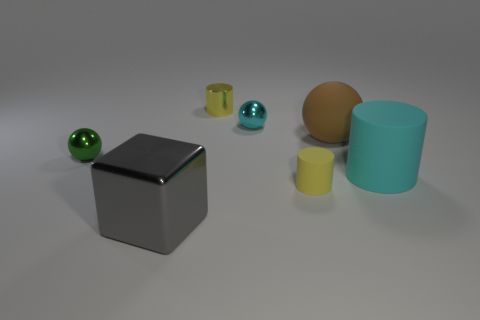Could these objects have a functional relationship, or are they purely decorative? These objects seem to be more decorative than functional. Their random arrangement and varying sizes and materials suggest they're meant for aesthetic display rather than practical use. 